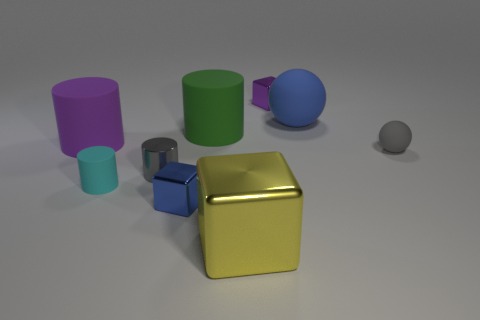Subtract all red cylinders. Subtract all yellow spheres. How many cylinders are left? 4 Add 1 blocks. How many objects exist? 10 Subtract all cubes. How many objects are left? 6 Add 2 brown things. How many brown things exist? 2 Subtract 0 red cylinders. How many objects are left? 9 Subtract all blue balls. Subtract all big green rubber objects. How many objects are left? 7 Add 8 tiny gray things. How many tiny gray things are left? 10 